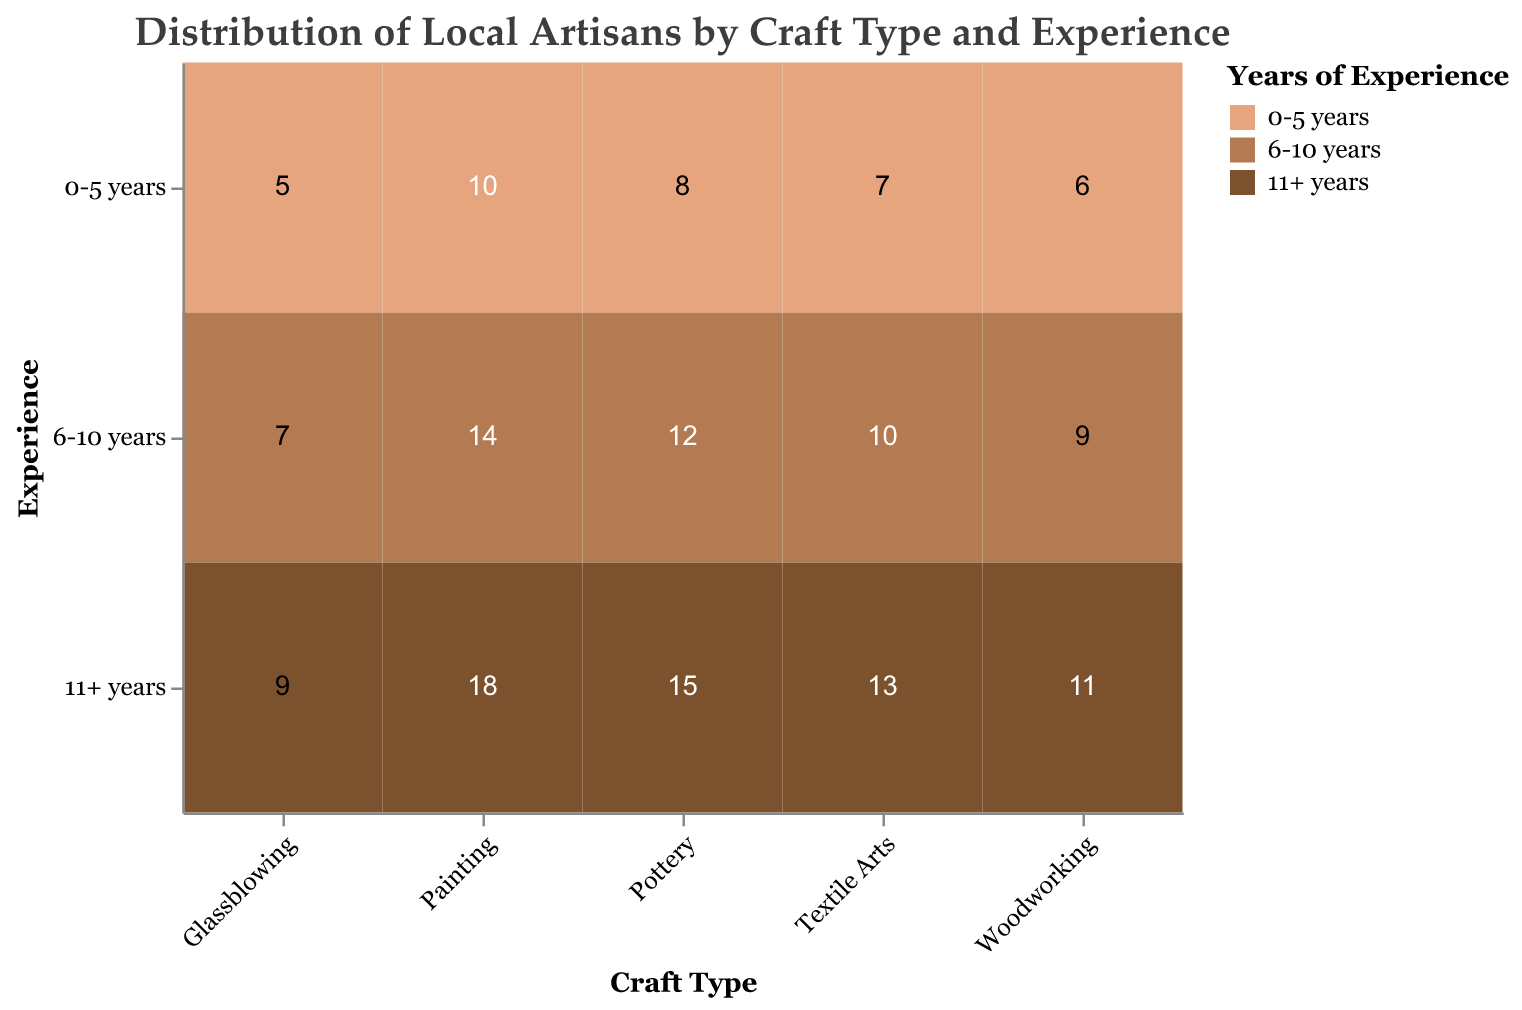Which craft type has the highest number of artisans with 11+ years of experience? We need to look at the count for each craft type in the 11+ years experience category. Pottery has 15, Painting has 18, Glassblowing has 9, Woodworking has 11, and Textile Arts has 13. Painting has the highest number with 18 artisans.
Answer: Painting What is the total number of artisans with 6-10 years of experience across all craft types? Sum the counts in the 6-10 years experience category for all craft types: Pottery (12) + Painting (14) + Glassblowing (7) + Woodworking (9) + Textile Arts (10) = 52.
Answer: 52 How many more artisans are there in Painting with 11+ years of experience compared to Glassblowing with 0-5 years? The count for Painting with 11+ years of experience is 18, and for Glassblowing with 0-5 years it is 5. The difference is 18 - 5 = 13.
Answer: 13 Which craft type has the most evenly distributed artisans across all experience levels? By observing the counts across experience levels for each craft type: Pottery (8, 12, 15), Painting (10, 14, 18), Glassblowing (5, 7, 9), Woodworking (6, 9, 11), and Textile Arts (7, 10, 13), it appears Glassblowing is the most evenly distributed.
Answer: Glassblowing Among all artisans with 0-5 years of experience, which craft type has the least representation? We examine the counts for each craft type in the 0-5 years experience category: Pottery (8), Painting (10), Glassblowing (5), Woodworking (6), Textile Arts (7). Glassblowing has the least representation with 5 artisans.
Answer: Glassblowing Which craft type has the highest total number of artisans regardless of years of experience? We sum the counts across all experience levels for each craft type: Pottery (8 + 12 + 15 = 35), Painting (10 + 14 + 18 = 42), Glassblowing (5 + 7 + 9 = 21), Woodworking (6 + 9 + 11 = 26), Textile Arts (7 + 10 + 13 = 30). Painting has the highest total with 42 artisans.
Answer: Painting If we combine the artisans with 11+ years of experience from Pottery and Painting, how many are there? We add the count for Pottery (15) and Painting (18) in the 11+ years experience category: 15 + 18 = 33.
Answer: 33 